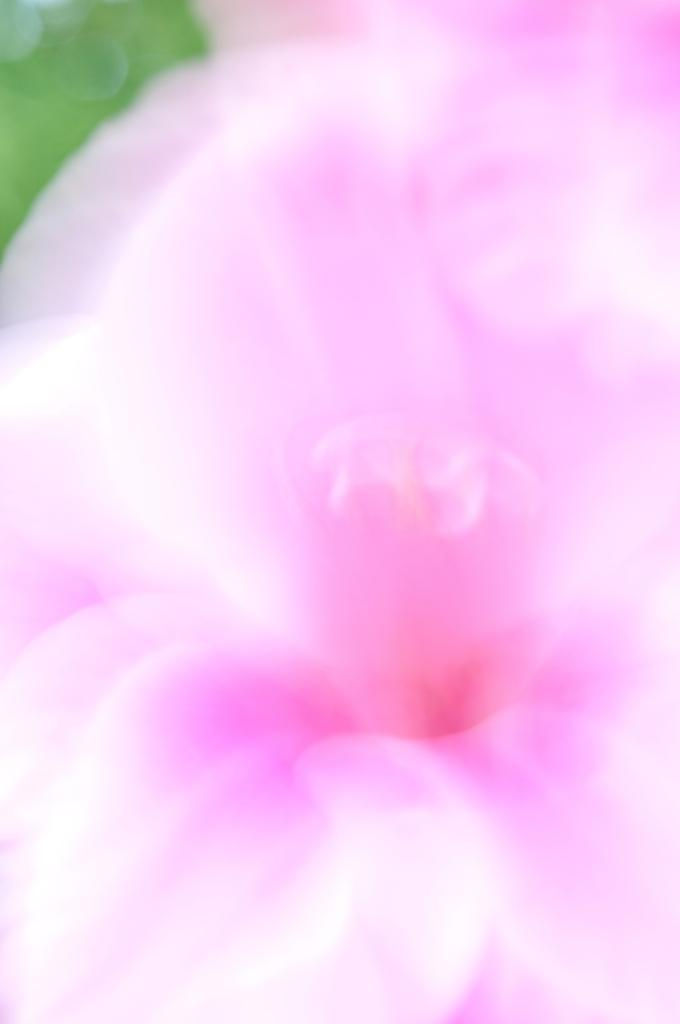What type of flower can be seen in the image? There is a pink color flower in the image. How well can the flower be seen in the image? The flower is not clearly visible in the image. What type of approval is required for the flower in the image? There is no indication in the image that any approval is required for the flower. 